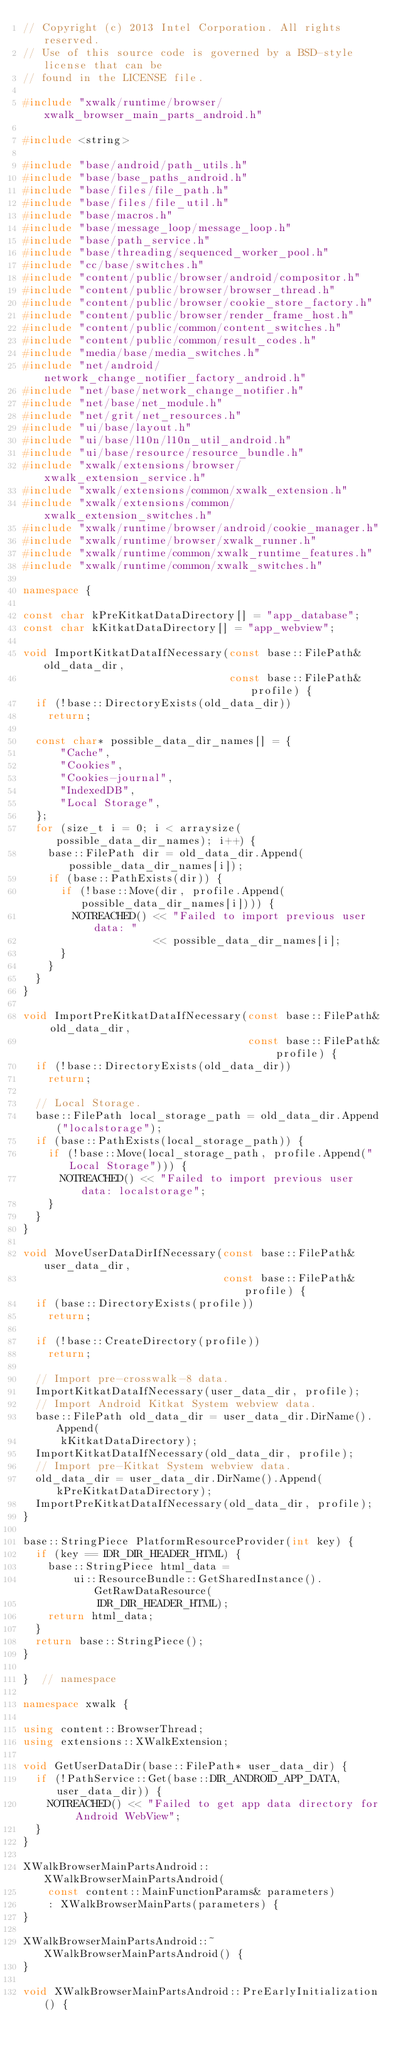Convert code to text. <code><loc_0><loc_0><loc_500><loc_500><_C++_>// Copyright (c) 2013 Intel Corporation. All rights reserved.
// Use of this source code is governed by a BSD-style license that can be
// found in the LICENSE file.

#include "xwalk/runtime/browser/xwalk_browser_main_parts_android.h"

#include <string>

#include "base/android/path_utils.h"
#include "base/base_paths_android.h"
#include "base/files/file_path.h"
#include "base/files/file_util.h"
#include "base/macros.h"
#include "base/message_loop/message_loop.h"
#include "base/path_service.h"
#include "base/threading/sequenced_worker_pool.h"
#include "cc/base/switches.h"
#include "content/public/browser/android/compositor.h"
#include "content/public/browser/browser_thread.h"
#include "content/public/browser/cookie_store_factory.h"
#include "content/public/browser/render_frame_host.h"
#include "content/public/common/content_switches.h"
#include "content/public/common/result_codes.h"
#include "media/base/media_switches.h"
#include "net/android/network_change_notifier_factory_android.h"
#include "net/base/network_change_notifier.h"
#include "net/base/net_module.h"
#include "net/grit/net_resources.h"
#include "ui/base/layout.h"
#include "ui/base/l10n/l10n_util_android.h"
#include "ui/base/resource/resource_bundle.h"
#include "xwalk/extensions/browser/xwalk_extension_service.h"
#include "xwalk/extensions/common/xwalk_extension.h"
#include "xwalk/extensions/common/xwalk_extension_switches.h"
#include "xwalk/runtime/browser/android/cookie_manager.h"
#include "xwalk/runtime/browser/xwalk_runner.h"
#include "xwalk/runtime/common/xwalk_runtime_features.h"
#include "xwalk/runtime/common/xwalk_switches.h"

namespace {

const char kPreKitkatDataDirectory[] = "app_database";
const char kKitkatDataDirectory[] = "app_webview";

void ImportKitkatDataIfNecessary(const base::FilePath& old_data_dir,
                                 const base::FilePath& profile) {
  if (!base::DirectoryExists(old_data_dir))
    return;

  const char* possible_data_dir_names[] = {
      "Cache",
      "Cookies",
      "Cookies-journal",
      "IndexedDB",
      "Local Storage",
  };
  for (size_t i = 0; i < arraysize(possible_data_dir_names); i++) {
    base::FilePath dir = old_data_dir.Append(possible_data_dir_names[i]);
    if (base::PathExists(dir)) {
      if (!base::Move(dir, profile.Append(possible_data_dir_names[i]))) {
        NOTREACHED() << "Failed to import previous user data: "
                     << possible_data_dir_names[i];
      }
    }
  }
}

void ImportPreKitkatDataIfNecessary(const base::FilePath& old_data_dir,
                                    const base::FilePath& profile) {
  if (!base::DirectoryExists(old_data_dir))
    return;

  // Local Storage.
  base::FilePath local_storage_path = old_data_dir.Append("localstorage");
  if (base::PathExists(local_storage_path)) {
    if (!base::Move(local_storage_path, profile.Append("Local Storage"))) {
      NOTREACHED() << "Failed to import previous user data: localstorage";
    }
  }
}

void MoveUserDataDirIfNecessary(const base::FilePath& user_data_dir,
                                const base::FilePath& profile) {
  if (base::DirectoryExists(profile))
    return;

  if (!base::CreateDirectory(profile))
    return;

  // Import pre-crosswalk-8 data.
  ImportKitkatDataIfNecessary(user_data_dir, profile);
  // Import Android Kitkat System webview data.
  base::FilePath old_data_dir = user_data_dir.DirName().Append(
      kKitkatDataDirectory);
  ImportKitkatDataIfNecessary(old_data_dir, profile);
  // Import pre-Kitkat System webview data.
  old_data_dir = user_data_dir.DirName().Append(kPreKitkatDataDirectory);
  ImportPreKitkatDataIfNecessary(old_data_dir, profile);
}

base::StringPiece PlatformResourceProvider(int key) {
  if (key == IDR_DIR_HEADER_HTML) {
    base::StringPiece html_data =
        ui::ResourceBundle::GetSharedInstance().GetRawDataResource(
            IDR_DIR_HEADER_HTML);
    return html_data;
  }
  return base::StringPiece();
}

}  // namespace

namespace xwalk {

using content::BrowserThread;
using extensions::XWalkExtension;

void GetUserDataDir(base::FilePath* user_data_dir) {
  if (!PathService::Get(base::DIR_ANDROID_APP_DATA, user_data_dir)) {
    NOTREACHED() << "Failed to get app data directory for Android WebView";
  }
}

XWalkBrowserMainPartsAndroid::XWalkBrowserMainPartsAndroid(
    const content::MainFunctionParams& parameters)
    : XWalkBrowserMainParts(parameters) {
}

XWalkBrowserMainPartsAndroid::~XWalkBrowserMainPartsAndroid() {
}

void XWalkBrowserMainPartsAndroid::PreEarlyInitialization() {</code> 